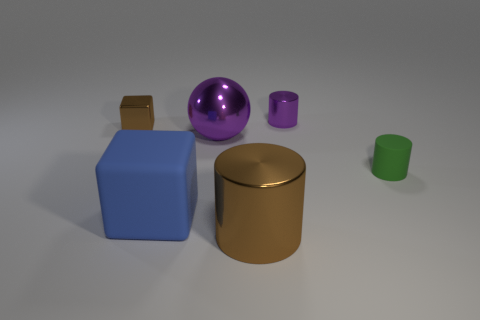Subtract all green cylinders. Subtract all gray balls. How many cylinders are left? 2 Add 2 large blue matte spheres. How many objects exist? 8 Subtract all blocks. How many objects are left? 4 Add 6 metal cylinders. How many metal cylinders exist? 8 Subtract 0 yellow spheres. How many objects are left? 6 Subtract all big metal spheres. Subtract all purple metal things. How many objects are left? 3 Add 1 large brown metal cylinders. How many large brown metal cylinders are left? 2 